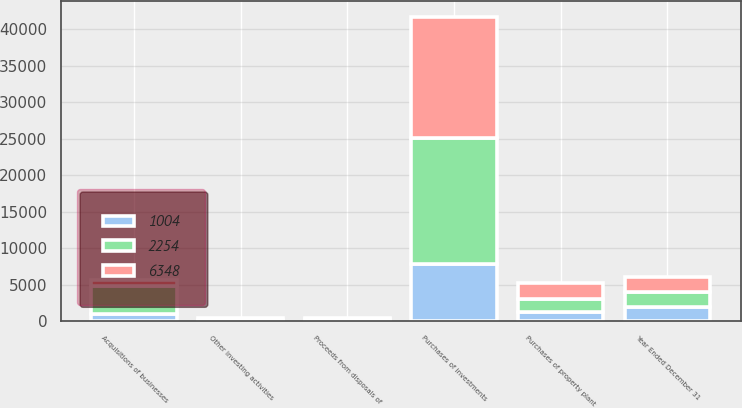<chart> <loc_0><loc_0><loc_500><loc_500><stacked_bar_chart><ecel><fcel>Year Ended December 31<fcel>Purchases of investments<fcel>Proceeds from disposals of<fcel>Acquisitions of businesses<fcel>Purchases of property plant<fcel>Other investing activities<nl><fcel>1004<fcel>2018<fcel>7789<fcel>245<fcel>1040<fcel>1347<fcel>60<nl><fcel>2254<fcel>2017<fcel>17296<fcel>104<fcel>3809<fcel>1675<fcel>93<nl><fcel>6348<fcel>2016<fcel>16626<fcel>150<fcel>838<fcel>2262<fcel>305<nl></chart> 